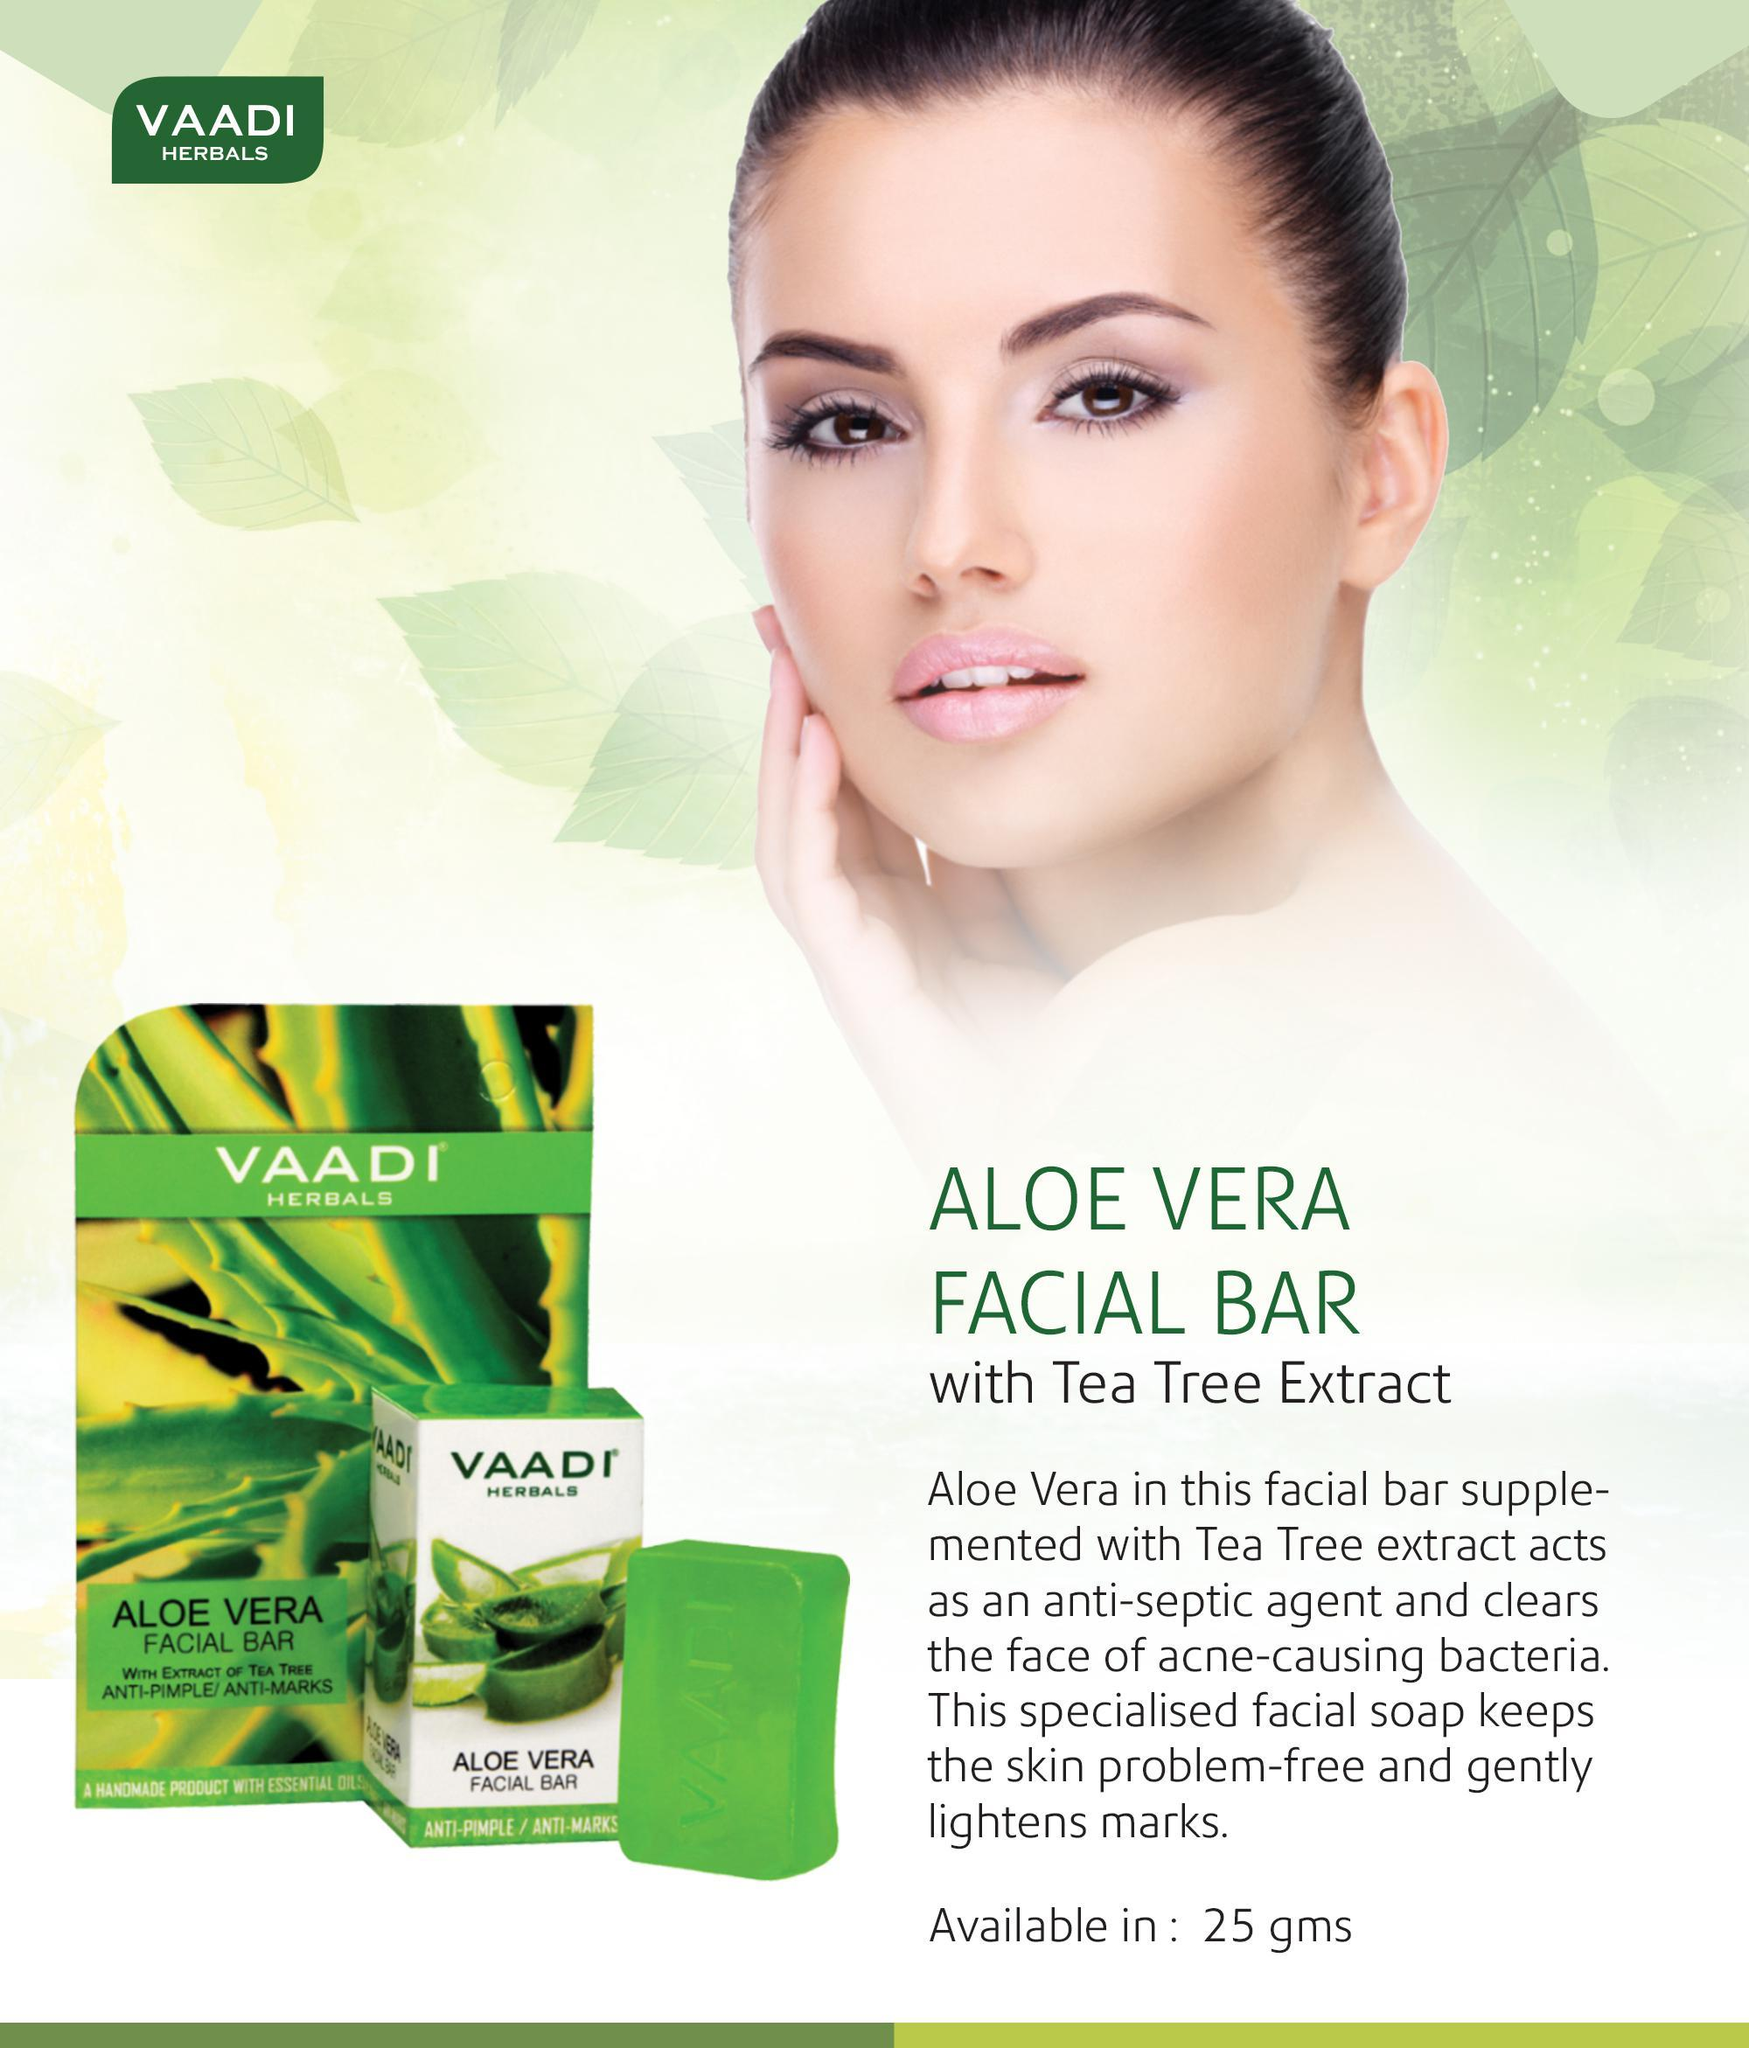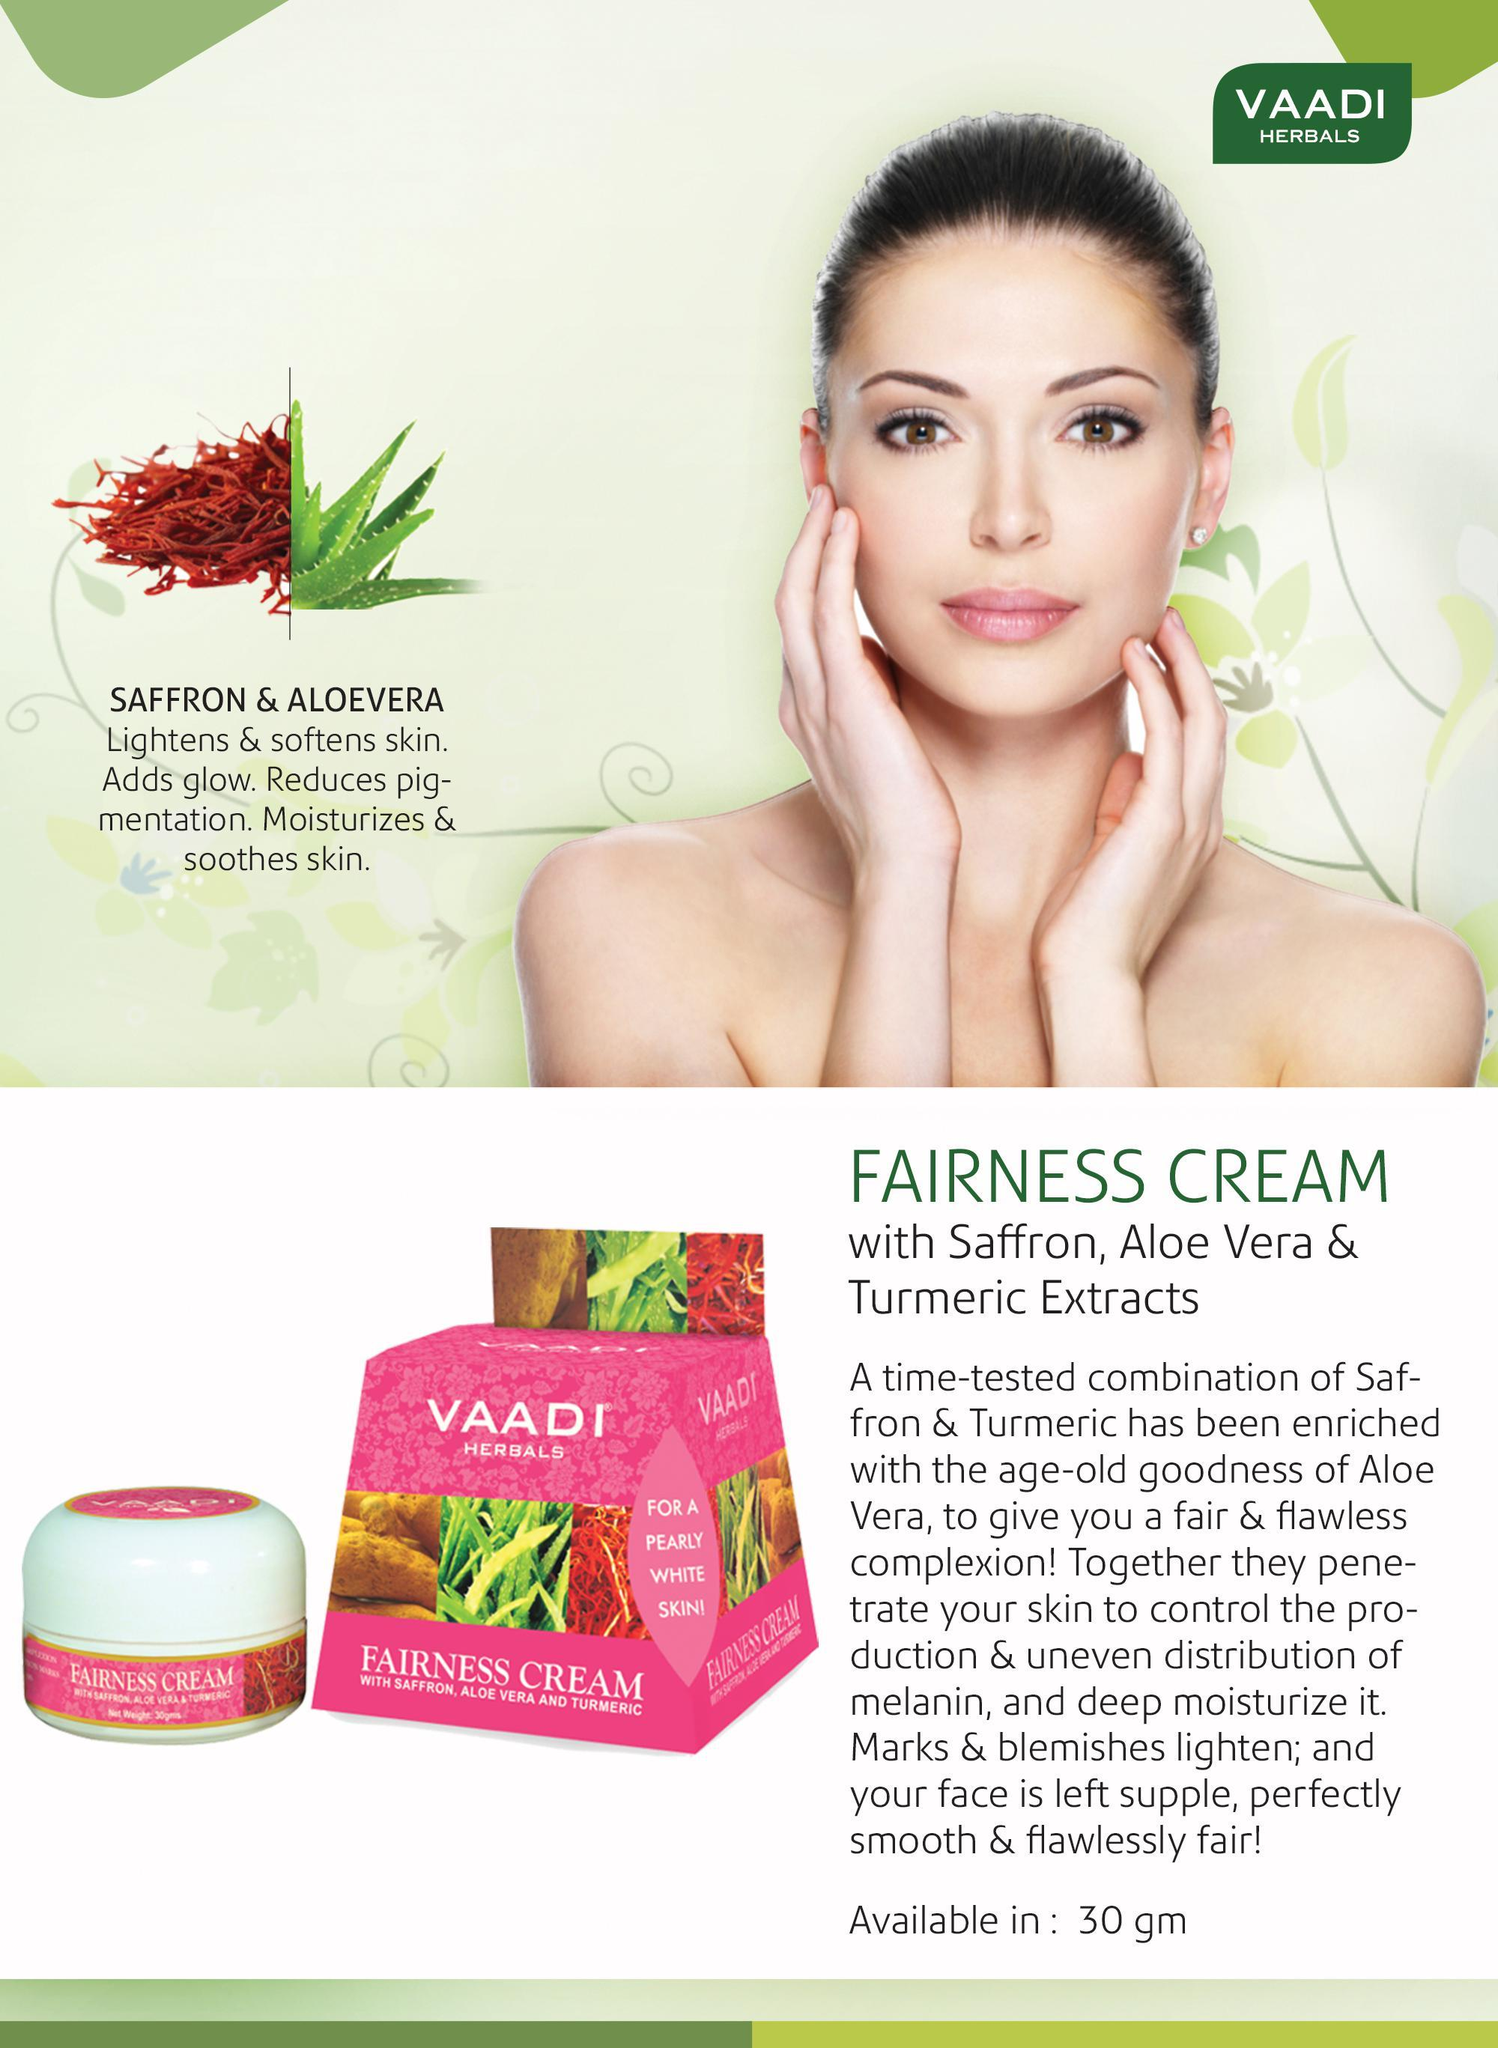The first image is the image on the left, the second image is the image on the right. Evaluate the accuracy of this statement regarding the images: "At least one woman has her hand on her face.". Is it true? Answer yes or no. Yes. The first image is the image on the left, the second image is the image on the right. Given the left and right images, does the statement "An ad image shows a model with slicked-back hair holding exactly one hand on her cheek." hold true? Answer yes or no. Yes. 